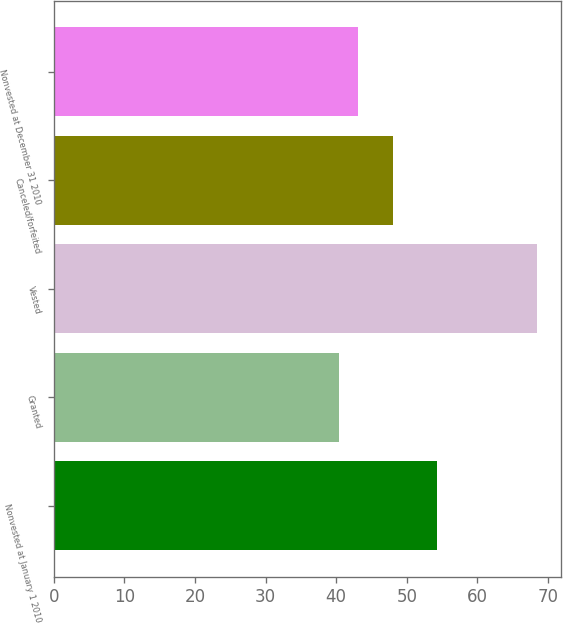<chart> <loc_0><loc_0><loc_500><loc_500><bar_chart><fcel>Nonvested at January 1 2010<fcel>Granted<fcel>Vested<fcel>Canceled/forfeited<fcel>Nonvested at December 31 2010<nl><fcel>54.34<fcel>40.34<fcel>68.41<fcel>48.06<fcel>43.15<nl></chart> 